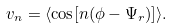Convert formula to latex. <formula><loc_0><loc_0><loc_500><loc_500>v _ { n } = \langle \cos [ n ( \phi - \Psi _ { r } ) ] \rangle .</formula> 